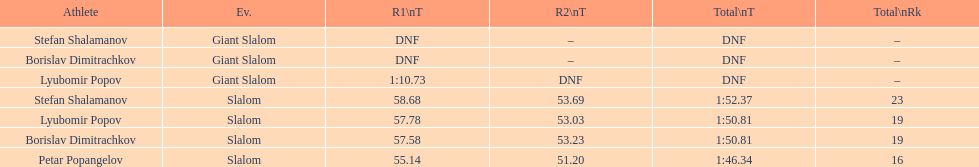What is the rank number of stefan shalamanov in the slalom event 23. 